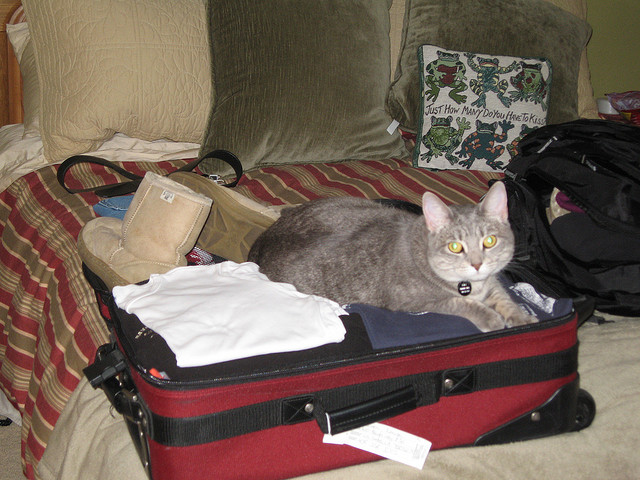Identify and read out the text in this image. JUST How MANY Do Kiss to You 